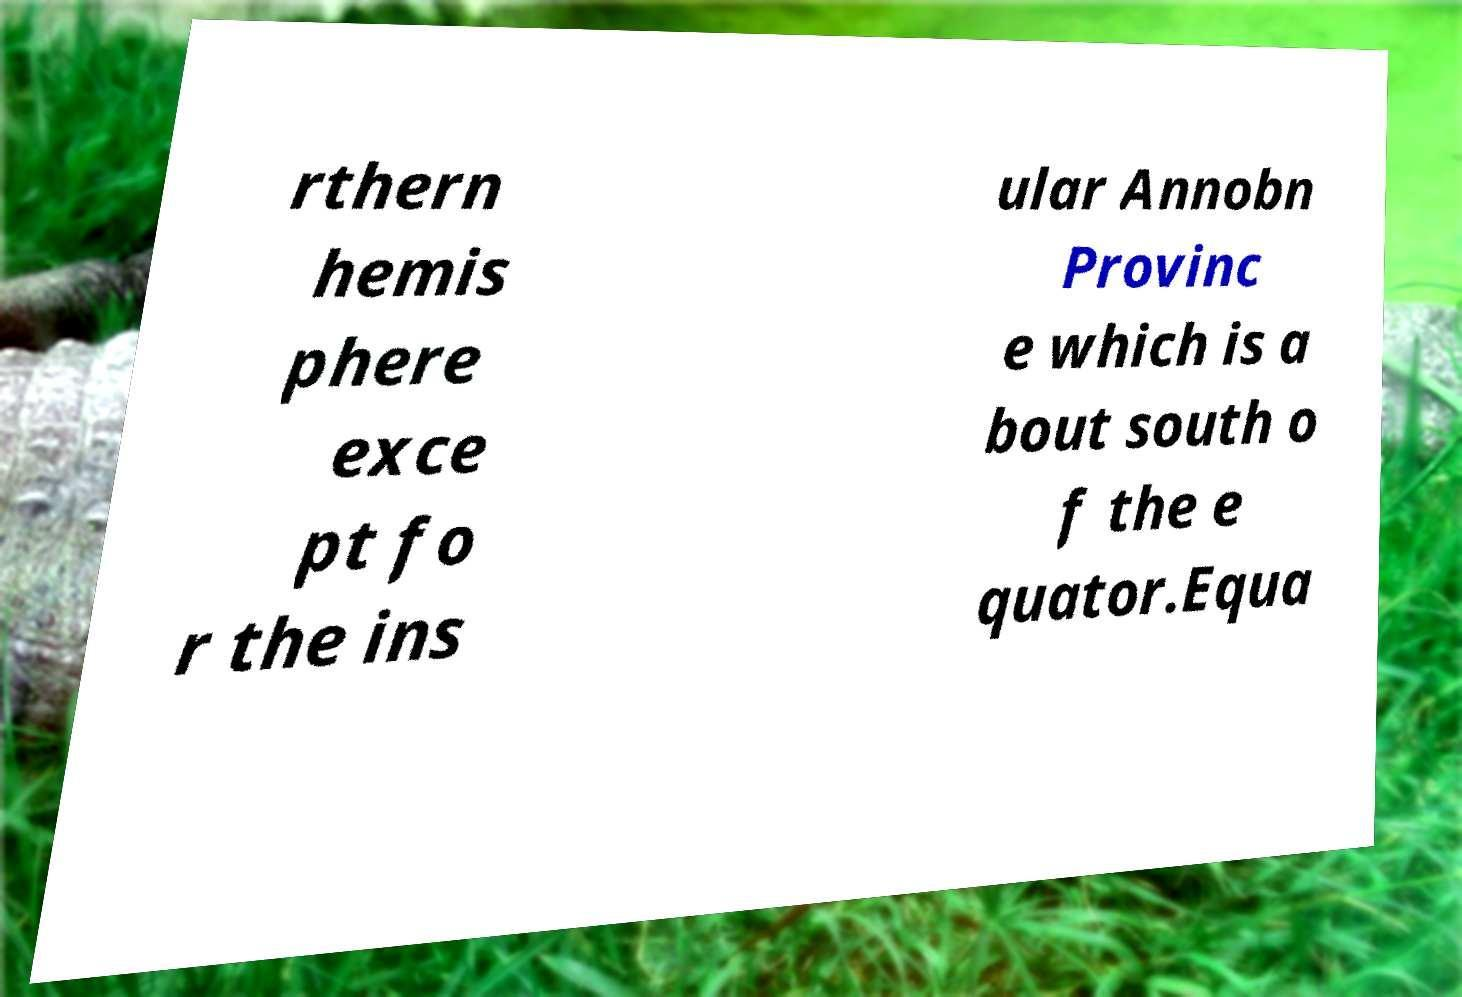Please read and relay the text visible in this image. What does it say? rthern hemis phere exce pt fo r the ins ular Annobn Provinc e which is a bout south o f the e quator.Equa 